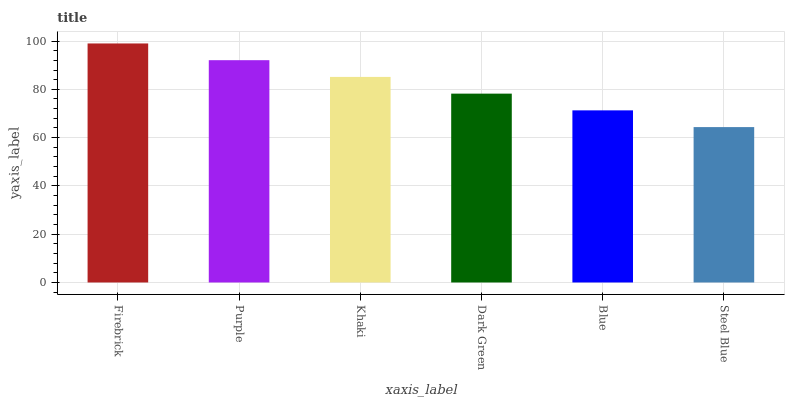Is Steel Blue the minimum?
Answer yes or no. Yes. Is Firebrick the maximum?
Answer yes or no. Yes. Is Purple the minimum?
Answer yes or no. No. Is Purple the maximum?
Answer yes or no. No. Is Firebrick greater than Purple?
Answer yes or no. Yes. Is Purple less than Firebrick?
Answer yes or no. Yes. Is Purple greater than Firebrick?
Answer yes or no. No. Is Firebrick less than Purple?
Answer yes or no. No. Is Khaki the high median?
Answer yes or no. Yes. Is Dark Green the low median?
Answer yes or no. Yes. Is Steel Blue the high median?
Answer yes or no. No. Is Steel Blue the low median?
Answer yes or no. No. 